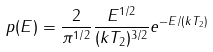Convert formula to latex. <formula><loc_0><loc_0><loc_500><loc_500>p ( E ) = \frac { 2 } { \pi ^ { 1 / 2 } } \frac { E ^ { 1 / 2 } } { ( k T _ { 2 } ) ^ { 3 / 2 } } e ^ { - E / ( k T _ { 2 } ) }</formula> 